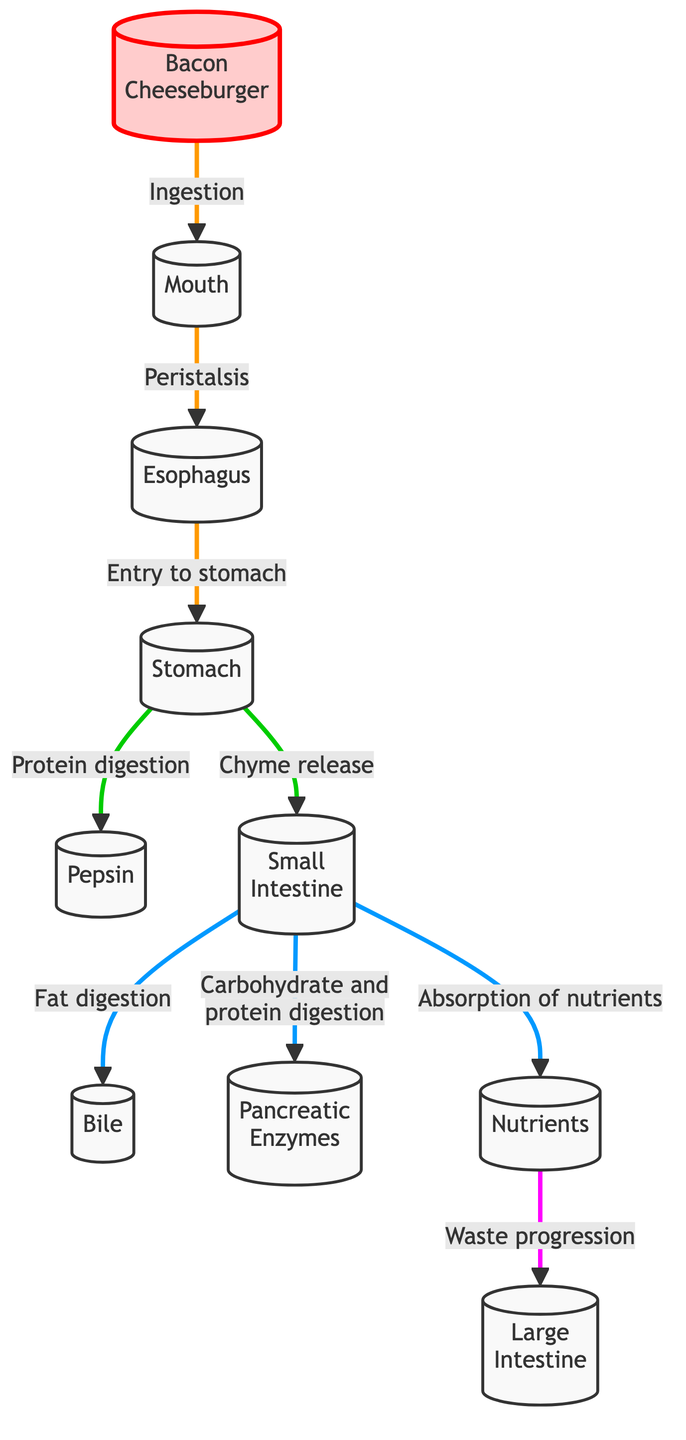What is the first step in the metabolic pathway? The diagram starts with the ingestion of the bacon cheeseburger, which is represented as the first node, labeled "Bacon Cheeseburger."
Answer: Bacon Cheeseburger How many nodes are in the metabolic pathway? Counting all unique stages, from "Bacon Cheeseburger" to "Large Intestine," there are ten distinct nodes in the flowchart.
Answer: 10 Which organ is responsible for the release of bile? The diagram indicates that bile is released in the small intestine, which is connected to the node labeled "Bile."
Answer: Small Intestine What is the relationship between the stomach and pepsin? The diagram shows a direct connection from the stomach to the enzyme pepsin, indicating that pepsin is involved in protein digestion occurring in the stomach.
Answer: Protein digestion Where does carbohydrate and protein digestion primarily occur? According to the flowchart, carbohydrate and protein digestion take place in the small intestine as indicated by the connection from "Small Intestine" to "Pancreatic Enzymes."
Answer: Small Intestine What is the purpose of the nutrients in this metabolic pathway? The diagram specifies that nutrients are absorbed after digestion, which indicates their role in providing essential substances for the body after the small intestine.
Answer: Absorption of nutrients Which process occurs before the entry to the stomach? The process that occurs prior to entry to the stomach is peristalsis, as indicated in the diagram flow from the esophagus to the stomach.
Answer: Peristalsis What is released from the stomach into the small intestine? The diagram shows that "Chyme" is released from the stomach into the small intestine, indicating the mixture of partially digested food.
Answer: Chyme release Which enzyme is involved in fat digestion? The diagram illustrates that bile, which is responsible for fat digestion, is introduced in the small intestine.
Answer: Bile 